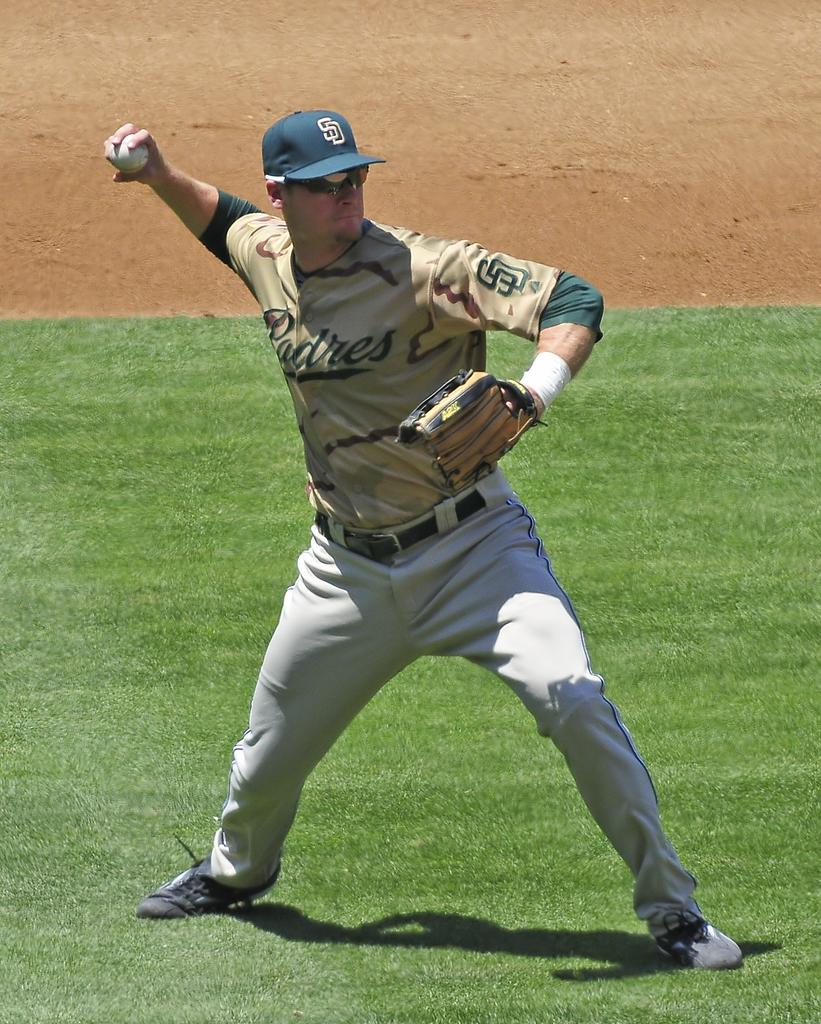<image>
Write a terse but informative summary of the picture. A man is wearing a Padres uniform on a baseball field. 